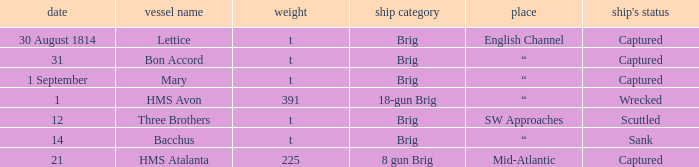What date was a brig type ship located in SW Approaches? 12.0. 